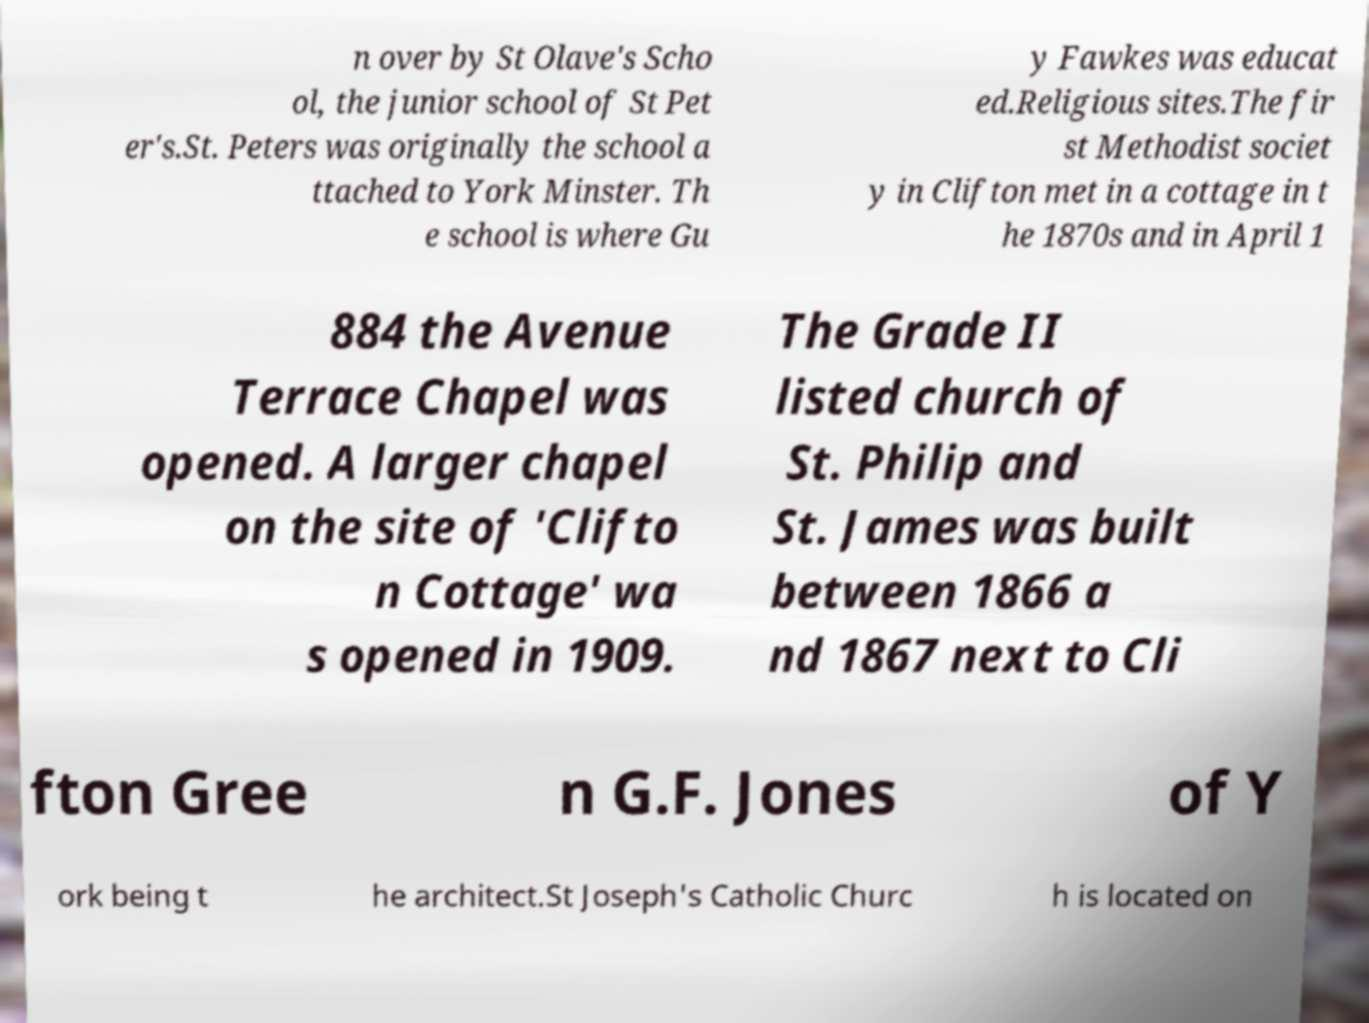Can you read and provide the text displayed in the image?This photo seems to have some interesting text. Can you extract and type it out for me? n over by St Olave's Scho ol, the junior school of St Pet er's.St. Peters was originally the school a ttached to York Minster. Th e school is where Gu y Fawkes was educat ed.Religious sites.The fir st Methodist societ y in Clifton met in a cottage in t he 1870s and in April 1 884 the Avenue Terrace Chapel was opened. A larger chapel on the site of 'Clifto n Cottage' wa s opened in 1909. The Grade II listed church of St. Philip and St. James was built between 1866 a nd 1867 next to Cli fton Gree n G.F. Jones of Y ork being t he architect.St Joseph's Catholic Churc h is located on 